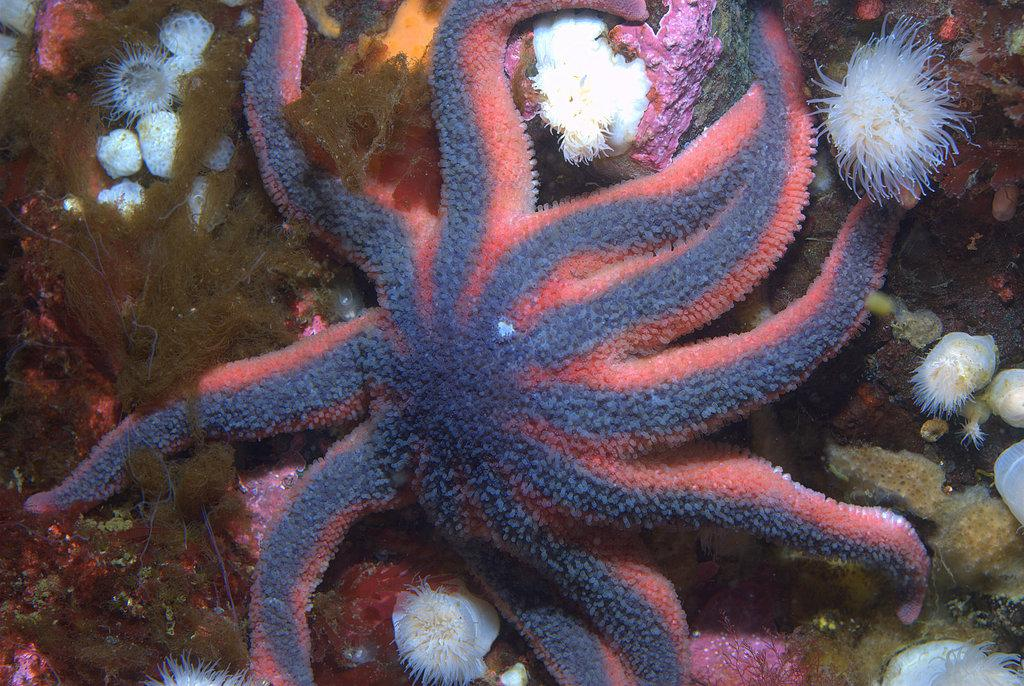What type of animal is in the image? There is a starfish in the image. Where is the starfish located? The starfish is on the ground underwater. What else can be seen in the image besides the starfish? There are stones and small aquatic plants visible in the image. How many wings does the starfish have in the image? Starfish do not have wings; they have five arms. However, since the image only shows the starfish and not its arms, we cannot definitively say how many "wings" it has in the image. 